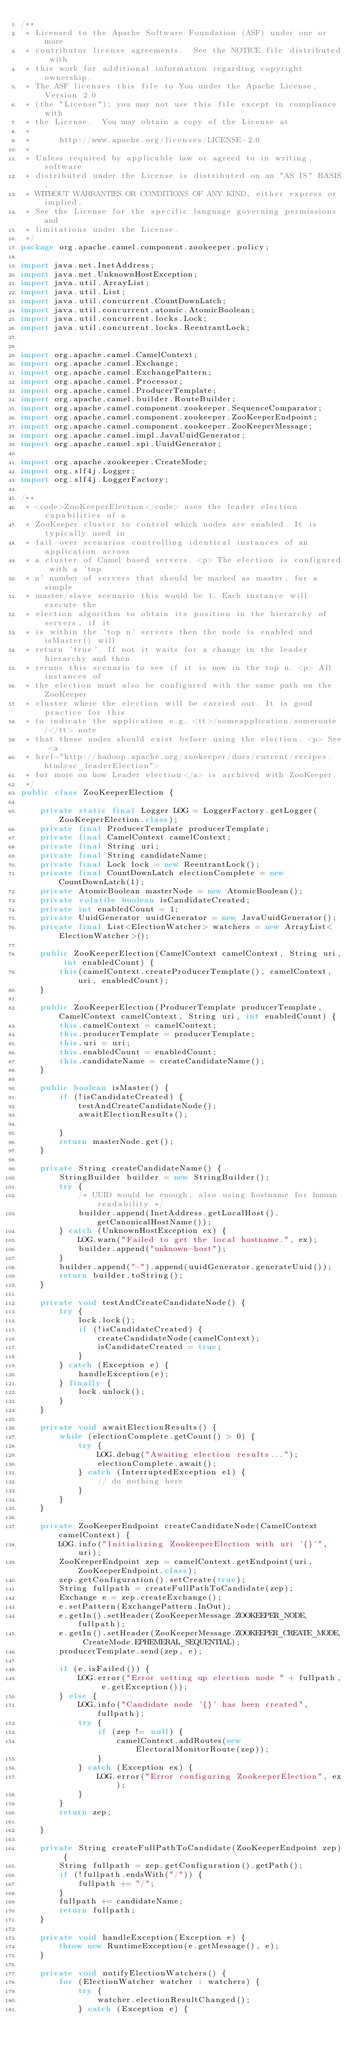<code> <loc_0><loc_0><loc_500><loc_500><_Java_>/**
 * Licensed to the Apache Software Foundation (ASF) under one or more
 * contributor license agreements.  See the NOTICE file distributed with
 * this work for additional information regarding copyright ownership.
 * The ASF licenses this file to You under the Apache License, Version 2.0
 * (the "License"); you may not use this file except in compliance with
 * the License.  You may obtain a copy of the License at
 *
 *      http://www.apache.org/licenses/LICENSE-2.0
 *
 * Unless required by applicable law or agreed to in writing, software
 * distributed under the License is distributed on an "AS IS" BASIS,
 * WITHOUT WARRANTIES OR CONDITIONS OF ANY KIND, either express or implied.
 * See the License for the specific language governing permissions and
 * limitations under the License.
 */
package org.apache.camel.component.zookeeper.policy;

import java.net.InetAddress;
import java.net.UnknownHostException;
import java.util.ArrayList;
import java.util.List;
import java.util.concurrent.CountDownLatch;
import java.util.concurrent.atomic.AtomicBoolean;
import java.util.concurrent.locks.Lock;
import java.util.concurrent.locks.ReentrantLock;


import org.apache.camel.CamelContext;
import org.apache.camel.Exchange;
import org.apache.camel.ExchangePattern;
import org.apache.camel.Processor;
import org.apache.camel.ProducerTemplate;
import org.apache.camel.builder.RouteBuilder;
import org.apache.camel.component.zookeeper.SequenceComparator;
import org.apache.camel.component.zookeeper.ZooKeeperEndpoint;
import org.apache.camel.component.zookeeper.ZooKeeperMessage;
import org.apache.camel.impl.JavaUuidGenerator;
import org.apache.camel.spi.UuidGenerator;

import org.apache.zookeeper.CreateMode;
import org.slf4j.Logger;
import org.slf4j.LoggerFactory;

/**
 * <code>ZooKeeperElection</code> uses the leader election capabilities of a
 * ZooKeeper cluster to control which nodes are enabled. It is typically used in
 * fail-over scenarios controlling identical instances of an application across
 * a cluster of Camel based servers. <p> The election is configured with a 'top
 * n' number of servers that should be marked as master, for a simple
 * master/slave scenario this would be 1. Each instance will execute the
 * election algorithm to obtain its position in the hierarchy of servers, if it
 * is within the 'top n' servers then the node is enabled and isMaster() will
 * return 'true'. If not it waits for a change in the leader hierarchy and then
 * reruns this scenario to see if it is now in the top n. <p> All instances of
 * the election must also be configured with the same path on the ZooKeeper
 * cluster where the election will be carried out. It is good practice for this
 * to indicate the application e.g. <tt>/someapplication/someroute/</tt> note
 * that these nodes should exist before using the election. <p> See <a
 * href="http://hadoop.apache.org/zookeeper/docs/current/recipes.html#sc_leaderElection">
 * for more on how Leader election</a> is archived with ZooKeeper.
 */
public class ZooKeeperElection {

    private static final Logger LOG = LoggerFactory.getLogger(ZooKeeperElection.class);
    private final ProducerTemplate producerTemplate;
    private final CamelContext camelContext;
    private final String uri;
    private final String candidateName;
    private final Lock lock = new ReentrantLock();
    private final CountDownLatch electionComplete = new CountDownLatch(1);
    private AtomicBoolean masterNode = new AtomicBoolean();
    private volatile boolean isCandidateCreated;
    private int enabledCount = 1;
    private UuidGenerator uuidGenerator = new JavaUuidGenerator();
    private final List<ElectionWatcher> watchers = new ArrayList<ElectionWatcher>();

    public ZooKeeperElection(CamelContext camelContext, String uri, int enabledCount) {
        this(camelContext.createProducerTemplate(), camelContext, uri, enabledCount);
    }

    public ZooKeeperElection(ProducerTemplate producerTemplate, CamelContext camelContext, String uri, int enabledCount) {
        this.camelContext = camelContext;
        this.producerTemplate = producerTemplate;
        this.uri = uri;
        this.enabledCount = enabledCount;
        this.candidateName = createCandidateName();
    }

    public boolean isMaster() {
        if (!isCandidateCreated) {
            testAndCreateCandidateNode();
            awaitElectionResults();

        }
        return masterNode.get();
    }

    private String createCandidateName() {
        StringBuilder builder = new StringBuilder();
        try {
            /* UUID would be enough, also using hostname for human readability */
            builder.append(InetAddress.getLocalHost().getCanonicalHostName());
        } catch (UnknownHostException ex) {
            LOG.warn("Failed to get the local hostname.", ex);
            builder.append("unknown-host");
        }
        builder.append("-").append(uuidGenerator.generateUuid());
        return builder.toString();
    }

    private void testAndCreateCandidateNode() {
        try {
            lock.lock();
            if (!isCandidateCreated) {
                createCandidateNode(camelContext);
                isCandidateCreated = true;
            }
        } catch (Exception e) {
            handleException(e);
        } finally {
            lock.unlock();
        }
    }

    private void awaitElectionResults() {
        while (electionComplete.getCount() > 0) {
            try {
                LOG.debug("Awaiting election results...");
                electionComplete.await();
            } catch (InterruptedException e1) {
                // do nothing here
            }
        }
    }

    private ZooKeeperEndpoint createCandidateNode(CamelContext camelContext) {
        LOG.info("Initializing ZookeeperElection with uri '{}'", uri);
        ZooKeeperEndpoint zep = camelContext.getEndpoint(uri, ZooKeeperEndpoint.class);
        zep.getConfiguration().setCreate(true);
        String fullpath = createFullPathToCandidate(zep);
        Exchange e = zep.createExchange();
        e.setPattern(ExchangePattern.InOut);
        e.getIn().setHeader(ZooKeeperMessage.ZOOKEEPER_NODE, fullpath);
        e.getIn().setHeader(ZooKeeperMessage.ZOOKEEPER_CREATE_MODE, CreateMode.EPHEMERAL_SEQUENTIAL);
        producerTemplate.send(zep, e);

        if (e.isFailed()) {
            LOG.error("Error setting up election node " + fullpath, e.getException());
        } else {
            LOG.info("Candidate node '{}' has been created", fullpath);
            try {
                if (zep != null) {
                    camelContext.addRoutes(new ElectoralMonitorRoute(zep));
                }
            } catch (Exception ex) {
                LOG.error("Error configuring ZookeeperElection", ex);
            }
        }
        return zep;

    }

    private String createFullPathToCandidate(ZooKeeperEndpoint zep) {
        String fullpath = zep.getConfiguration().getPath();
        if (!fullpath.endsWith("/")) {
            fullpath += "/";
        }
        fullpath += candidateName;
        return fullpath;
    }

    private void handleException(Exception e) {
        throw new RuntimeException(e.getMessage(), e);
    }

    private void notifyElectionWatchers() {
        for (ElectionWatcher watcher : watchers) {
            try {
                watcher.electionResultChanged();
            } catch (Exception e) {</code> 